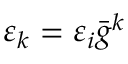<formula> <loc_0><loc_0><loc_500><loc_500>\varepsilon _ { k } = \varepsilon _ { i } \ B a r { g } ^ { k }</formula> 